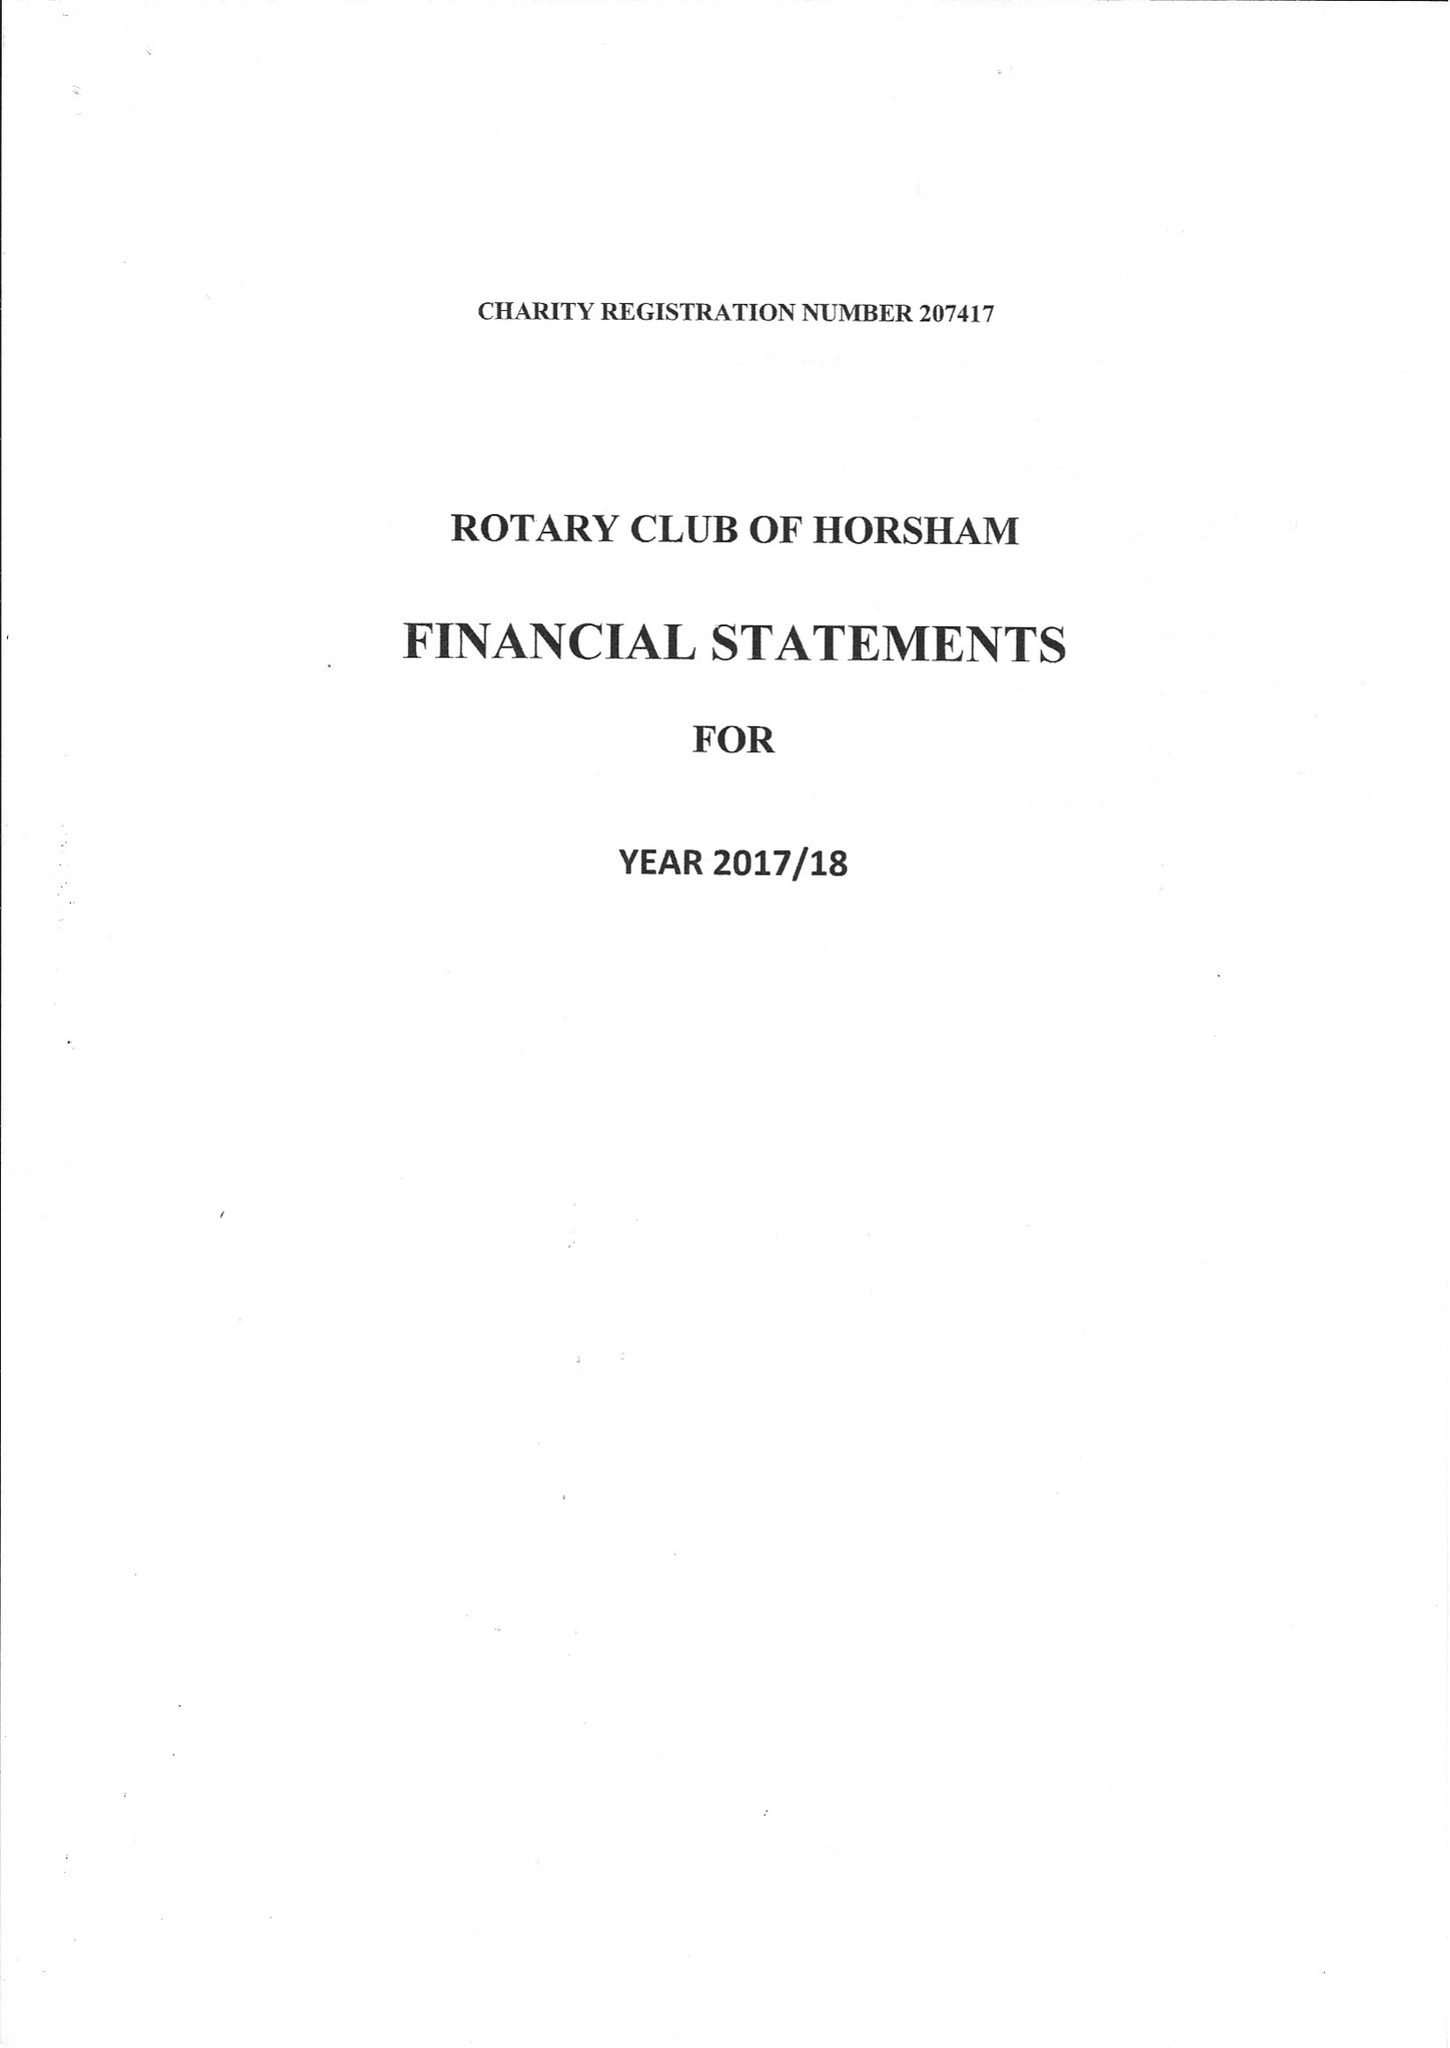What is the value for the report_date?
Answer the question using a single word or phrase. 2018-06-30 